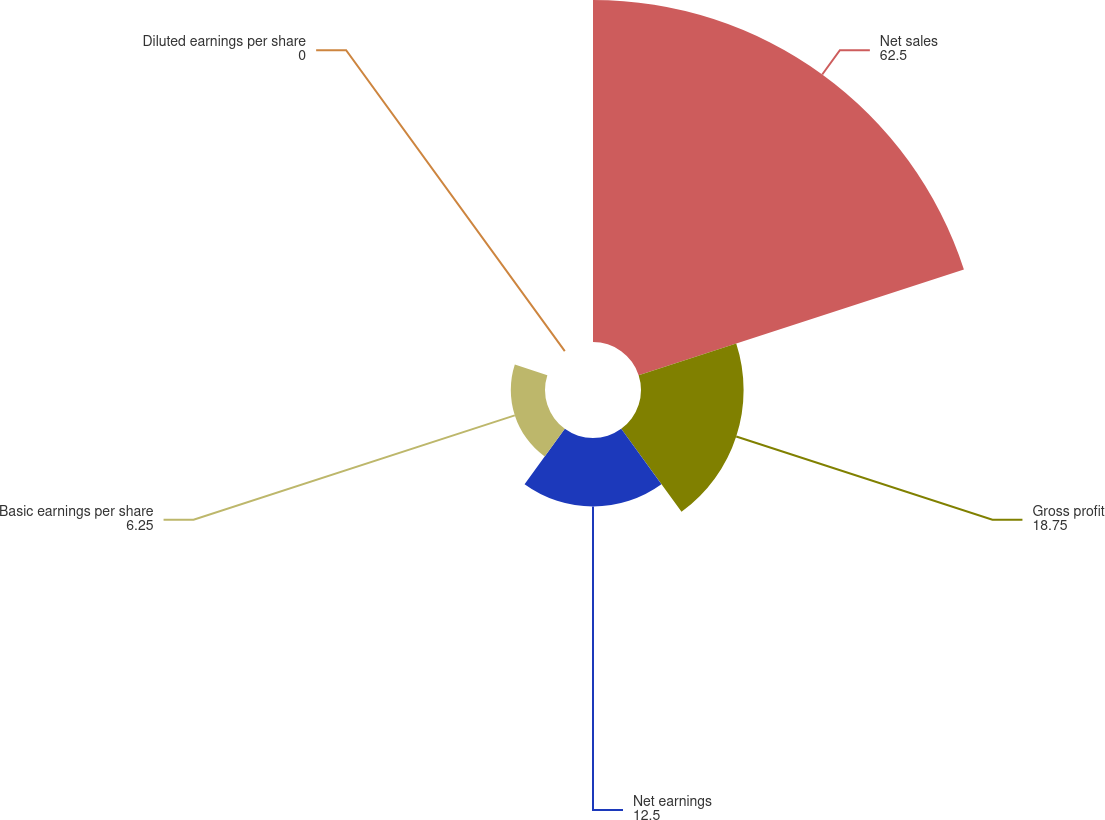Convert chart. <chart><loc_0><loc_0><loc_500><loc_500><pie_chart><fcel>Net sales<fcel>Gross profit<fcel>Net earnings<fcel>Basic earnings per share<fcel>Diluted earnings per share<nl><fcel>62.5%<fcel>18.75%<fcel>12.5%<fcel>6.25%<fcel>0.0%<nl></chart> 